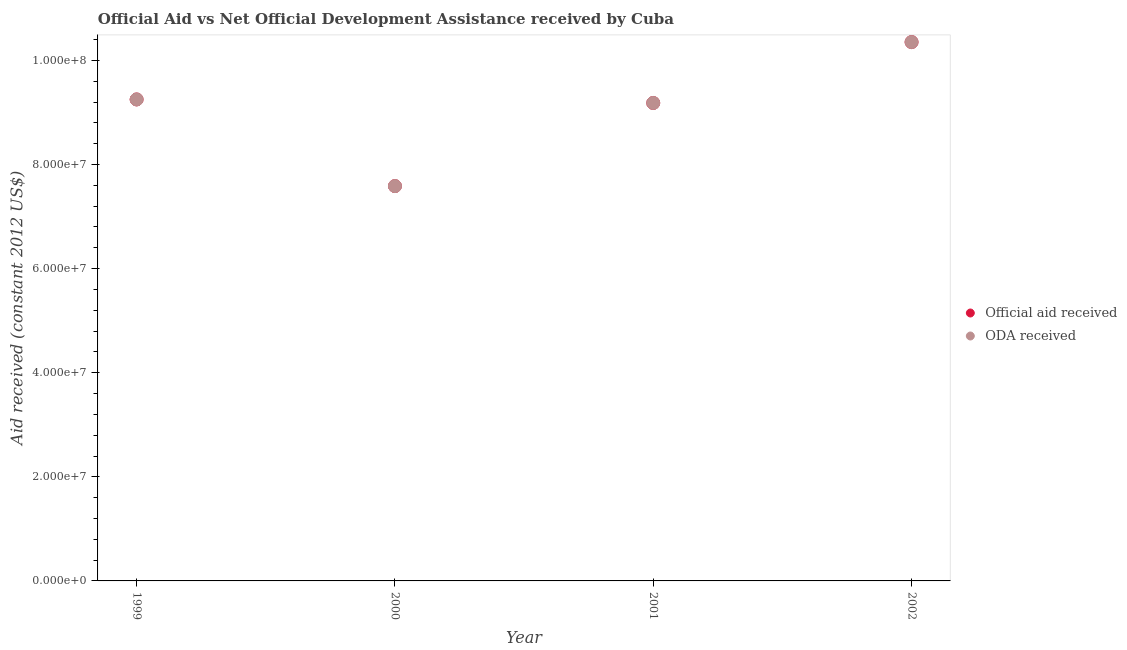Is the number of dotlines equal to the number of legend labels?
Your answer should be compact. Yes. What is the oda received in 2002?
Give a very brief answer. 1.04e+08. Across all years, what is the maximum official aid received?
Your response must be concise. 1.04e+08. Across all years, what is the minimum official aid received?
Your answer should be very brief. 7.59e+07. What is the total oda received in the graph?
Your answer should be compact. 3.64e+08. What is the difference between the official aid received in 1999 and that in 2000?
Ensure brevity in your answer.  1.66e+07. What is the difference between the oda received in 2001 and the official aid received in 2000?
Ensure brevity in your answer.  1.60e+07. What is the average official aid received per year?
Provide a short and direct response. 9.09e+07. In how many years, is the oda received greater than 84000000 US$?
Your answer should be compact. 3. What is the ratio of the official aid received in 2001 to that in 2002?
Your answer should be very brief. 0.89. Is the official aid received in 1999 less than that in 2000?
Make the answer very short. No. Is the difference between the official aid received in 1999 and 2001 greater than the difference between the oda received in 1999 and 2001?
Provide a succinct answer. No. What is the difference between the highest and the second highest oda received?
Your response must be concise. 1.10e+07. What is the difference between the highest and the lowest oda received?
Give a very brief answer. 2.77e+07. Does the oda received monotonically increase over the years?
Provide a succinct answer. No. Is the oda received strictly less than the official aid received over the years?
Offer a terse response. No. How many dotlines are there?
Offer a very short reply. 2. How many years are there in the graph?
Ensure brevity in your answer.  4. What is the difference between two consecutive major ticks on the Y-axis?
Your response must be concise. 2.00e+07. Are the values on the major ticks of Y-axis written in scientific E-notation?
Offer a very short reply. Yes. Does the graph contain any zero values?
Provide a short and direct response. No. Does the graph contain grids?
Your answer should be very brief. No. How many legend labels are there?
Make the answer very short. 2. How are the legend labels stacked?
Offer a very short reply. Vertical. What is the title of the graph?
Make the answer very short. Official Aid vs Net Official Development Assistance received by Cuba . Does "2012 US$" appear as one of the legend labels in the graph?
Keep it short and to the point. No. What is the label or title of the Y-axis?
Provide a short and direct response. Aid received (constant 2012 US$). What is the Aid received (constant 2012 US$) of Official aid received in 1999?
Provide a succinct answer. 9.25e+07. What is the Aid received (constant 2012 US$) of ODA received in 1999?
Offer a terse response. 9.25e+07. What is the Aid received (constant 2012 US$) in Official aid received in 2000?
Your response must be concise. 7.59e+07. What is the Aid received (constant 2012 US$) in ODA received in 2000?
Keep it short and to the point. 7.59e+07. What is the Aid received (constant 2012 US$) of Official aid received in 2001?
Provide a succinct answer. 9.18e+07. What is the Aid received (constant 2012 US$) in ODA received in 2001?
Provide a short and direct response. 9.18e+07. What is the Aid received (constant 2012 US$) in Official aid received in 2002?
Make the answer very short. 1.04e+08. What is the Aid received (constant 2012 US$) of ODA received in 2002?
Provide a succinct answer. 1.04e+08. Across all years, what is the maximum Aid received (constant 2012 US$) in Official aid received?
Provide a short and direct response. 1.04e+08. Across all years, what is the maximum Aid received (constant 2012 US$) in ODA received?
Offer a very short reply. 1.04e+08. Across all years, what is the minimum Aid received (constant 2012 US$) in Official aid received?
Your answer should be compact. 7.59e+07. Across all years, what is the minimum Aid received (constant 2012 US$) of ODA received?
Keep it short and to the point. 7.59e+07. What is the total Aid received (constant 2012 US$) of Official aid received in the graph?
Your response must be concise. 3.64e+08. What is the total Aid received (constant 2012 US$) in ODA received in the graph?
Keep it short and to the point. 3.64e+08. What is the difference between the Aid received (constant 2012 US$) of Official aid received in 1999 and that in 2000?
Make the answer very short. 1.66e+07. What is the difference between the Aid received (constant 2012 US$) of ODA received in 1999 and that in 2000?
Offer a very short reply. 1.66e+07. What is the difference between the Aid received (constant 2012 US$) of Official aid received in 1999 and that in 2001?
Make the answer very short. 6.80e+05. What is the difference between the Aid received (constant 2012 US$) of ODA received in 1999 and that in 2001?
Offer a very short reply. 6.80e+05. What is the difference between the Aid received (constant 2012 US$) in Official aid received in 1999 and that in 2002?
Your answer should be very brief. -1.10e+07. What is the difference between the Aid received (constant 2012 US$) of ODA received in 1999 and that in 2002?
Provide a succinct answer. -1.10e+07. What is the difference between the Aid received (constant 2012 US$) in Official aid received in 2000 and that in 2001?
Your answer should be very brief. -1.60e+07. What is the difference between the Aid received (constant 2012 US$) of ODA received in 2000 and that in 2001?
Offer a terse response. -1.60e+07. What is the difference between the Aid received (constant 2012 US$) of Official aid received in 2000 and that in 2002?
Give a very brief answer. -2.77e+07. What is the difference between the Aid received (constant 2012 US$) in ODA received in 2000 and that in 2002?
Provide a short and direct response. -2.77e+07. What is the difference between the Aid received (constant 2012 US$) of Official aid received in 2001 and that in 2002?
Give a very brief answer. -1.17e+07. What is the difference between the Aid received (constant 2012 US$) in ODA received in 2001 and that in 2002?
Make the answer very short. -1.17e+07. What is the difference between the Aid received (constant 2012 US$) of Official aid received in 1999 and the Aid received (constant 2012 US$) of ODA received in 2000?
Give a very brief answer. 1.66e+07. What is the difference between the Aid received (constant 2012 US$) of Official aid received in 1999 and the Aid received (constant 2012 US$) of ODA received in 2001?
Provide a short and direct response. 6.80e+05. What is the difference between the Aid received (constant 2012 US$) in Official aid received in 1999 and the Aid received (constant 2012 US$) in ODA received in 2002?
Make the answer very short. -1.10e+07. What is the difference between the Aid received (constant 2012 US$) in Official aid received in 2000 and the Aid received (constant 2012 US$) in ODA received in 2001?
Your response must be concise. -1.60e+07. What is the difference between the Aid received (constant 2012 US$) in Official aid received in 2000 and the Aid received (constant 2012 US$) in ODA received in 2002?
Provide a short and direct response. -2.77e+07. What is the difference between the Aid received (constant 2012 US$) of Official aid received in 2001 and the Aid received (constant 2012 US$) of ODA received in 2002?
Give a very brief answer. -1.17e+07. What is the average Aid received (constant 2012 US$) in Official aid received per year?
Ensure brevity in your answer.  9.09e+07. What is the average Aid received (constant 2012 US$) in ODA received per year?
Your response must be concise. 9.09e+07. In the year 2002, what is the difference between the Aid received (constant 2012 US$) in Official aid received and Aid received (constant 2012 US$) in ODA received?
Make the answer very short. 0. What is the ratio of the Aid received (constant 2012 US$) in Official aid received in 1999 to that in 2000?
Your answer should be compact. 1.22. What is the ratio of the Aid received (constant 2012 US$) of ODA received in 1999 to that in 2000?
Your answer should be compact. 1.22. What is the ratio of the Aid received (constant 2012 US$) in Official aid received in 1999 to that in 2001?
Give a very brief answer. 1.01. What is the ratio of the Aid received (constant 2012 US$) in ODA received in 1999 to that in 2001?
Give a very brief answer. 1.01. What is the ratio of the Aid received (constant 2012 US$) in Official aid received in 1999 to that in 2002?
Keep it short and to the point. 0.89. What is the ratio of the Aid received (constant 2012 US$) in ODA received in 1999 to that in 2002?
Give a very brief answer. 0.89. What is the ratio of the Aid received (constant 2012 US$) of Official aid received in 2000 to that in 2001?
Your answer should be compact. 0.83. What is the ratio of the Aid received (constant 2012 US$) of ODA received in 2000 to that in 2001?
Give a very brief answer. 0.83. What is the ratio of the Aid received (constant 2012 US$) of Official aid received in 2000 to that in 2002?
Your response must be concise. 0.73. What is the ratio of the Aid received (constant 2012 US$) of ODA received in 2000 to that in 2002?
Offer a terse response. 0.73. What is the ratio of the Aid received (constant 2012 US$) of Official aid received in 2001 to that in 2002?
Offer a terse response. 0.89. What is the ratio of the Aid received (constant 2012 US$) in ODA received in 2001 to that in 2002?
Offer a terse response. 0.89. What is the difference between the highest and the second highest Aid received (constant 2012 US$) in Official aid received?
Keep it short and to the point. 1.10e+07. What is the difference between the highest and the second highest Aid received (constant 2012 US$) of ODA received?
Provide a succinct answer. 1.10e+07. What is the difference between the highest and the lowest Aid received (constant 2012 US$) of Official aid received?
Provide a succinct answer. 2.77e+07. What is the difference between the highest and the lowest Aid received (constant 2012 US$) of ODA received?
Offer a very short reply. 2.77e+07. 